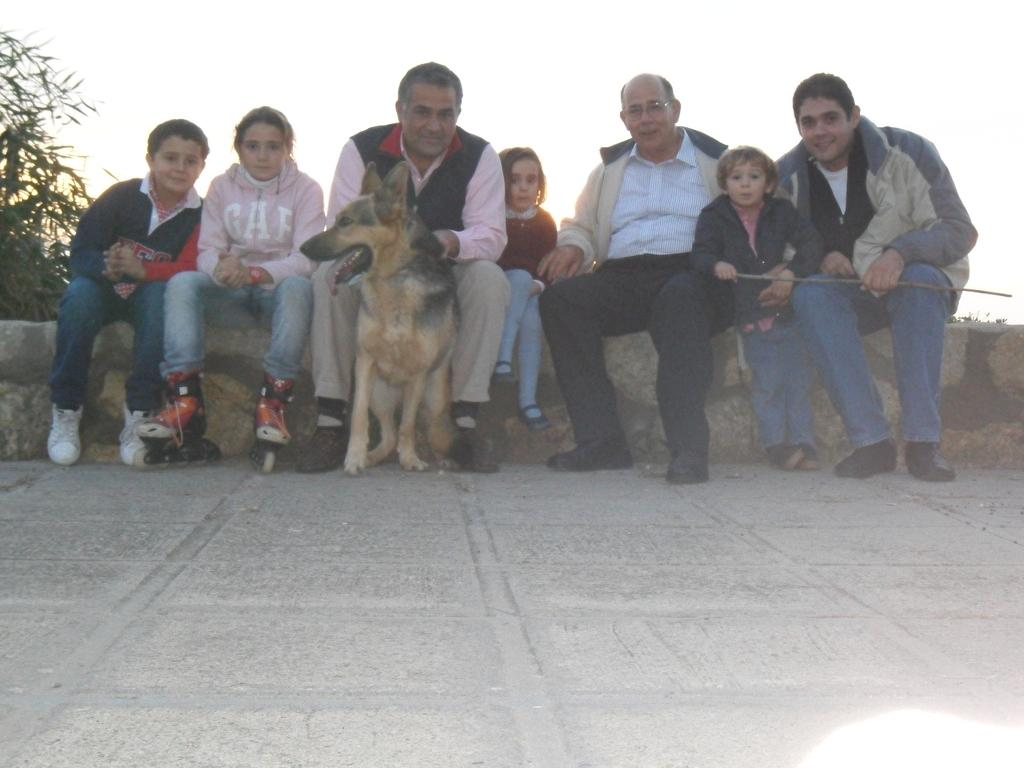What are the people in the image doing? There is a group of people sitting on a wall in the image. Can you describe anything behind the group of people? There is a dog behind the group of people. What can be seen in the background of the image? The sky is visible in the image. What type of tin can be seen hanging from the wall in the image? There is no tin present in the image; it features a group of people sitting on a wall with a dog behind them and the sky visible in the background. 